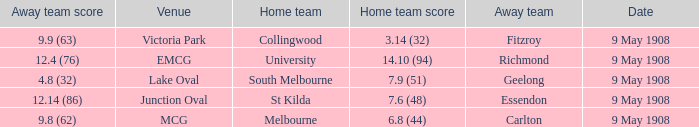Name the home team for carlton away team Melbourne. 